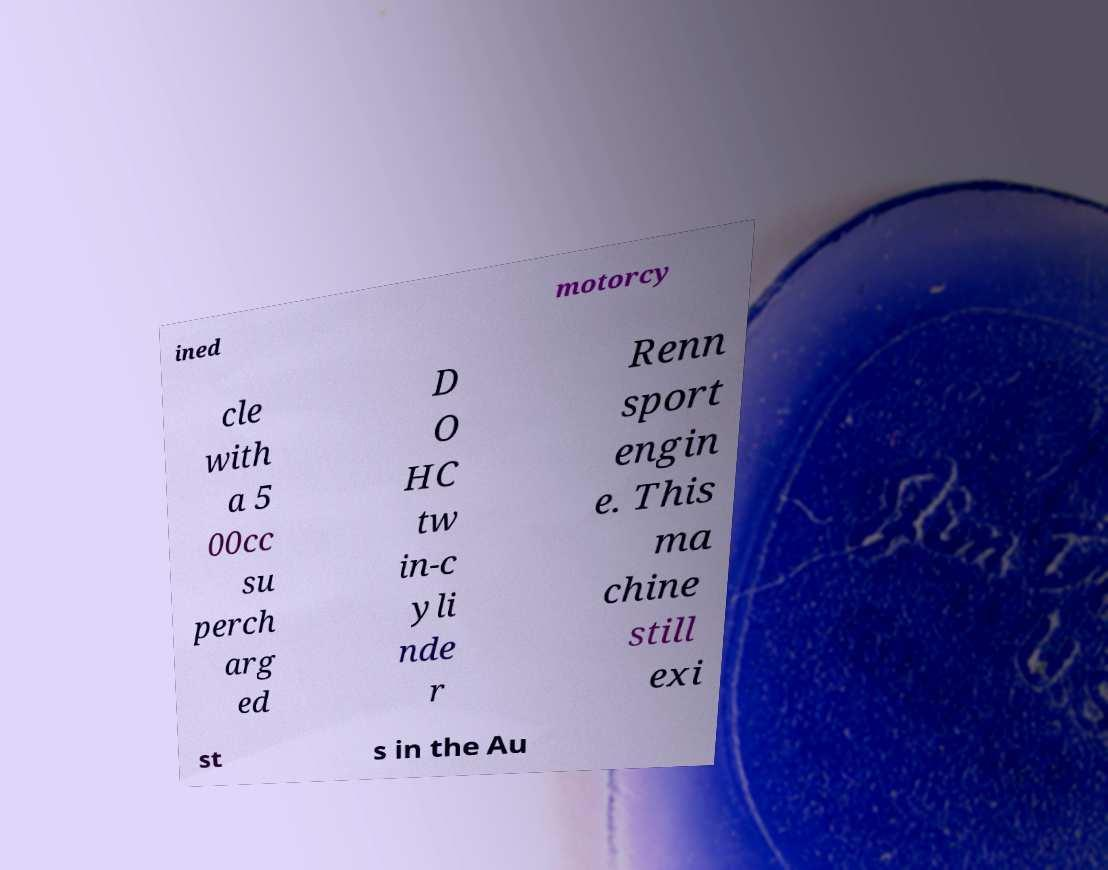There's text embedded in this image that I need extracted. Can you transcribe it verbatim? ined motorcy cle with a 5 00cc su perch arg ed D O HC tw in-c yli nde r Renn sport engin e. This ma chine still exi st s in the Au 